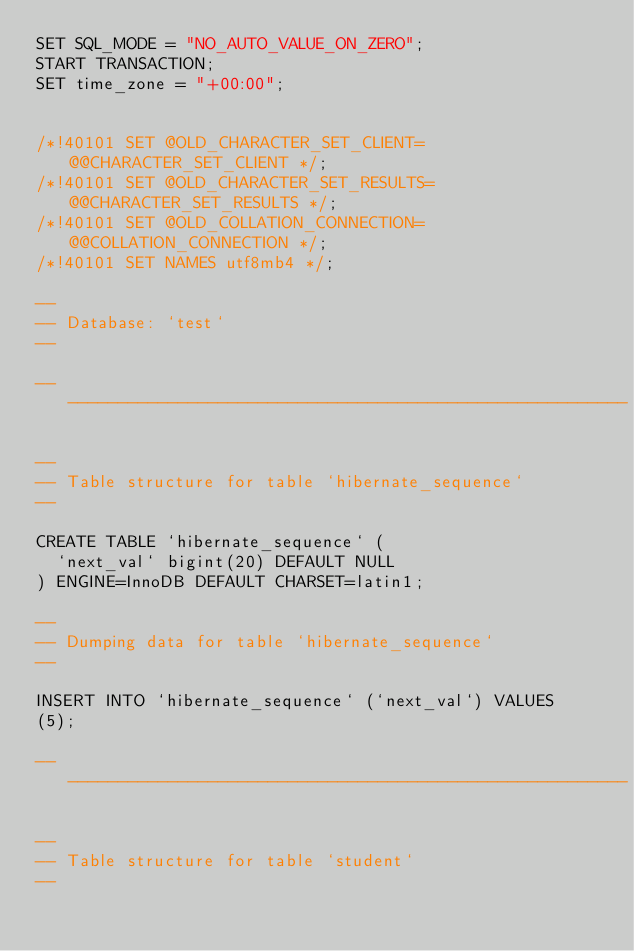Convert code to text. <code><loc_0><loc_0><loc_500><loc_500><_SQL_>SET SQL_MODE = "NO_AUTO_VALUE_ON_ZERO";
START TRANSACTION;
SET time_zone = "+00:00";


/*!40101 SET @OLD_CHARACTER_SET_CLIENT=@@CHARACTER_SET_CLIENT */;
/*!40101 SET @OLD_CHARACTER_SET_RESULTS=@@CHARACTER_SET_RESULTS */;
/*!40101 SET @OLD_COLLATION_CONNECTION=@@COLLATION_CONNECTION */;
/*!40101 SET NAMES utf8mb4 */;

--
-- Database: `test`
--

-- --------------------------------------------------------

--
-- Table structure for table `hibernate_sequence`
--

CREATE TABLE `hibernate_sequence` (
  `next_val` bigint(20) DEFAULT NULL
) ENGINE=InnoDB DEFAULT CHARSET=latin1;

--
-- Dumping data for table `hibernate_sequence`
--

INSERT INTO `hibernate_sequence` (`next_val`) VALUES
(5);

-- --------------------------------------------------------

--
-- Table structure for table `student`
--
</code> 